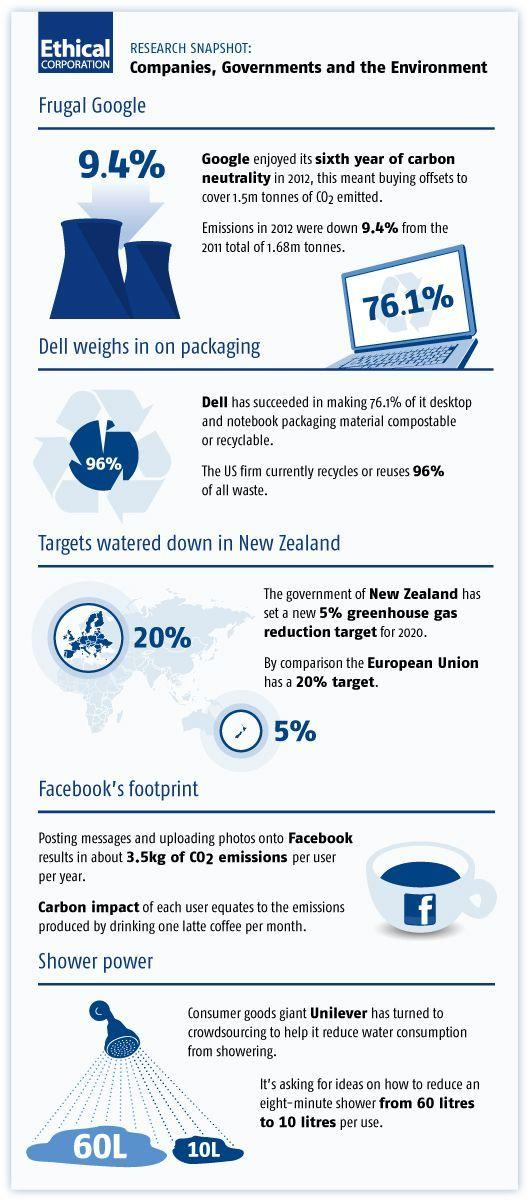List a handful of essential elements in this visual. The New Zealand and European Union aim to reduce their total carbon emissions by 25% by the year 2020. Unilever aims to achieve a water consumption target of 10 liters per day for all its operations by 2030. This target is part of the company's commitment to sustainable water management and reducing its water footprint. The specific water consumption target for Unilever is 60 liters per day, but the company is working towards a more ambitious target of 10 liters per day, with a long-term goal of reducing its water use to 3.5 liters per day. 